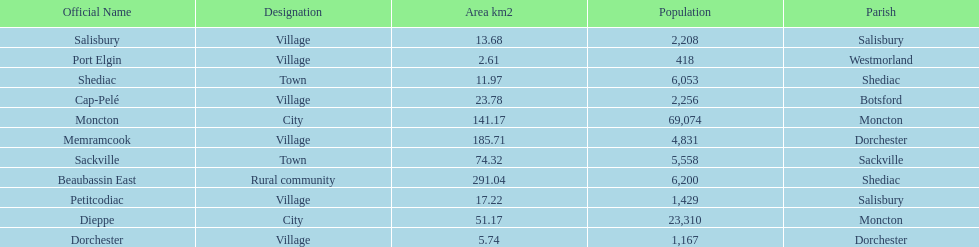Which municipality has the most number of people who reside in it? Moncton. 